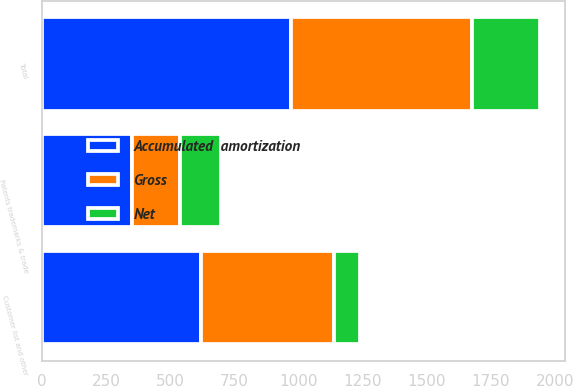<chart> <loc_0><loc_0><loc_500><loc_500><stacked_bar_chart><ecel><fcel>Patents trademarks & trade<fcel>Customer list and other<fcel>Total<nl><fcel>Accumulated  amortization<fcel>350<fcel>621<fcel>971<nl><fcel>Net<fcel>162<fcel>103<fcel>265<nl><fcel>Gross<fcel>188<fcel>518<fcel>706<nl></chart> 